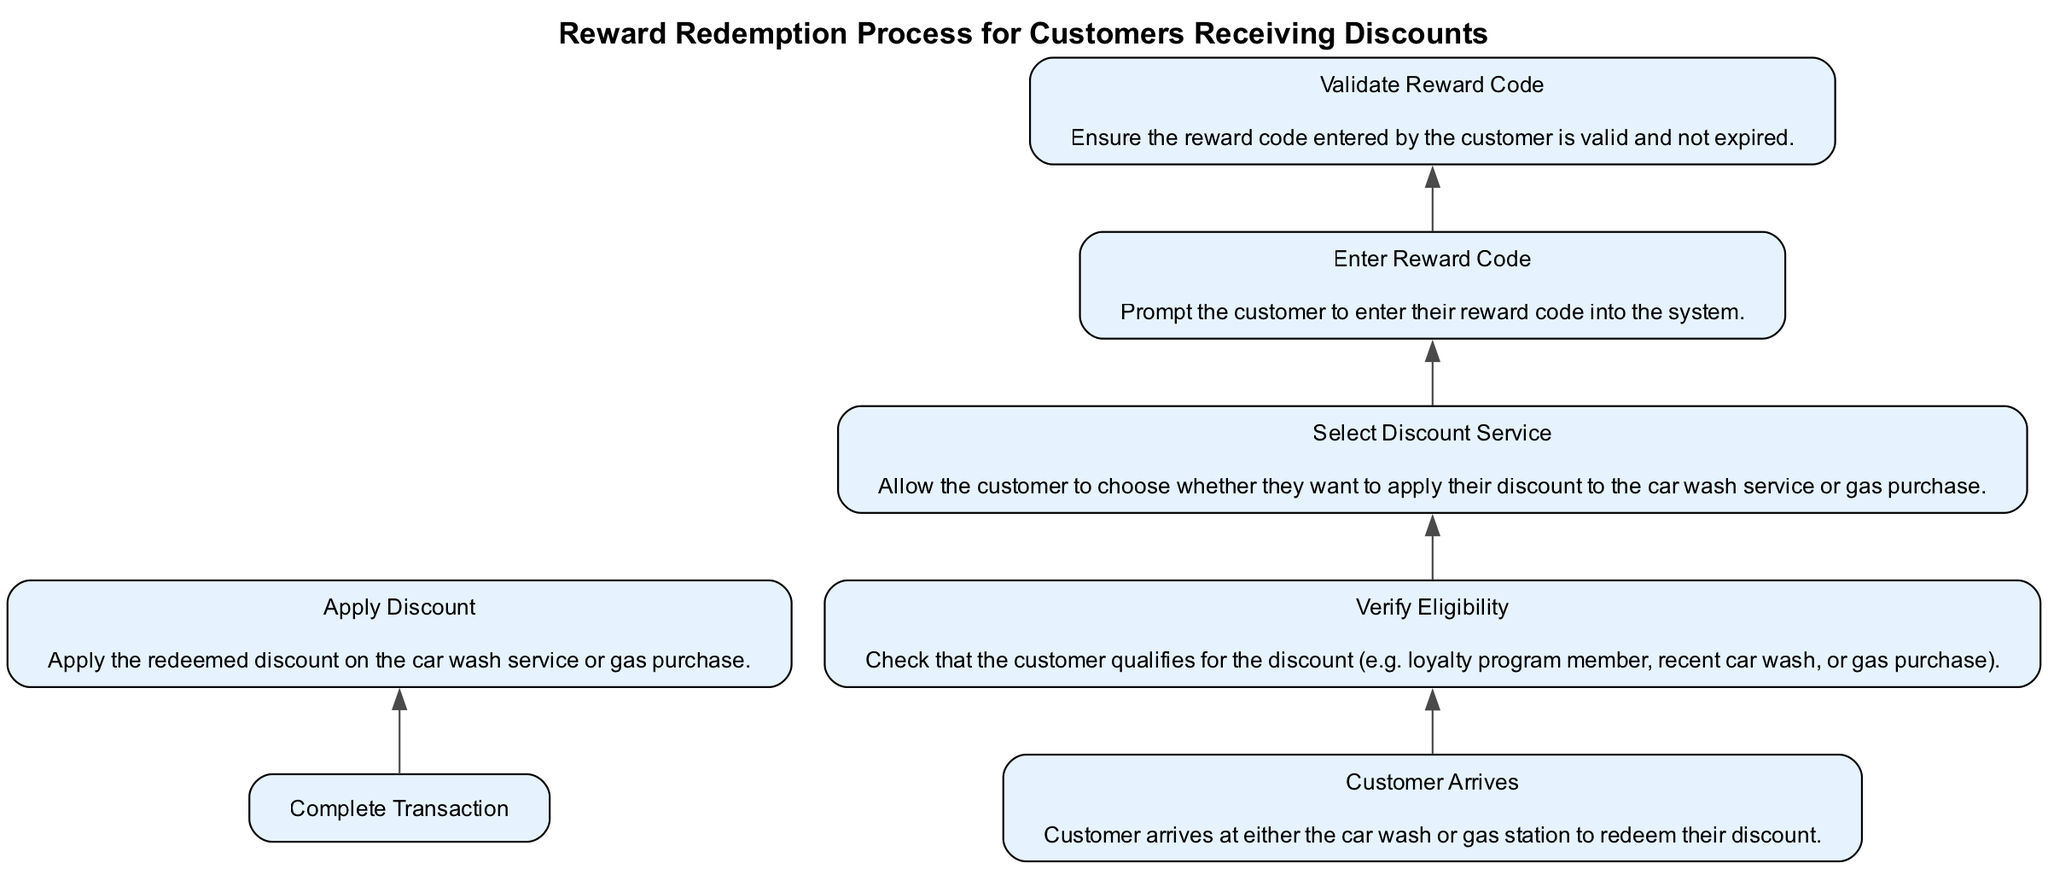What is the first step in the reward redemption process? The diagram shows "Customer Arrives" at the bottom as the first step before any other actions can be taken. This indicates that the customer must arrive at either the car wash or gas station first.
Answer: Customer Arrives How many total steps are there in the process? Counting all the nodes in the flowchart, there are six steps: Customer Arrives, Verify Eligibility, Select Discount Service, Enter Reward Code, Validate Reward Code, and Apply Discount.
Answer: Six Which step directly follows "Validate Reward Code"? The diagram indicates that "Apply Discount" follows after "Validate Reward Code," meaning this step occurs only if the reward code is validated as correct.
Answer: Apply Discount What is necessary before entering the reward code? According to the diagram, "Select Discount Service" must occur before "Enter Reward Code," meaning the customer needs to choose how they'd like to apply their discount first.
Answer: Select Discount Service What must be checked to verify eligibility for the discount? The "Verify Eligibility" step checks if the customer qualifies for the discount based on criteria such as being a loyalty program member or having made recent purchases.
Answer: Customer qualifications What does "Apply Discount" depend on? The diagram shows that "Apply Discount" is dependent on "Complete Transaction." This indicates that the discount can only be applied once the transaction is complete.
Answer: Complete Transaction What is the last action taken in the redemption process? The last action in the flow, as shown in the diagram, is "Apply Discount," indicating that this is the final step before concluding the redemption process.
Answer: Apply Discount What happens if the reward code is invalid? Since "Validate Reward Code" must happen before "Apply Discount," if the reward code is invalid the process cannot move forward to applying the discount, effectively stopping progress.
Answer: Process stops How many dependencies does "Enter Reward Code" have? The diagram indicates that "Enter Reward Code" has one dependency listed, which is "Select Discount Service." This means the selection step must be done first.
Answer: One dependency What action leads to "Verify Eligibility"? The "Customer Arrives" action is necessary to initiate the next step, which is verifying the customer's eligibility for the discount.
Answer: Customer Arrives 